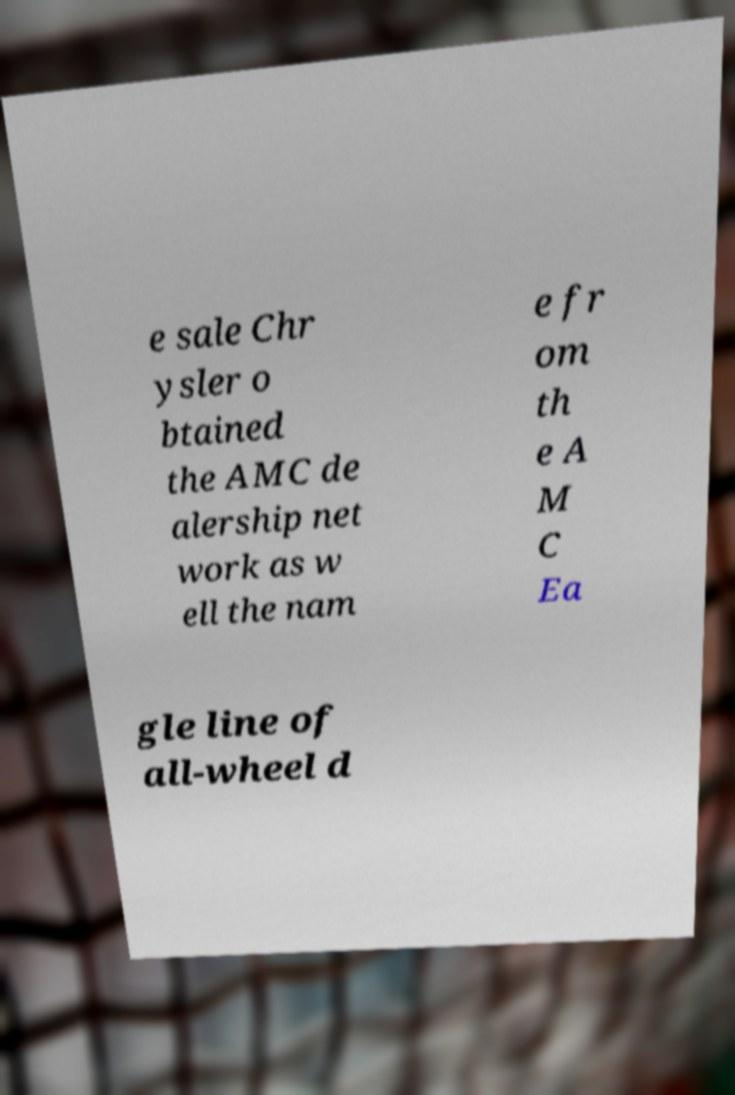There's text embedded in this image that I need extracted. Can you transcribe it verbatim? e sale Chr ysler o btained the AMC de alership net work as w ell the nam e fr om th e A M C Ea gle line of all-wheel d 